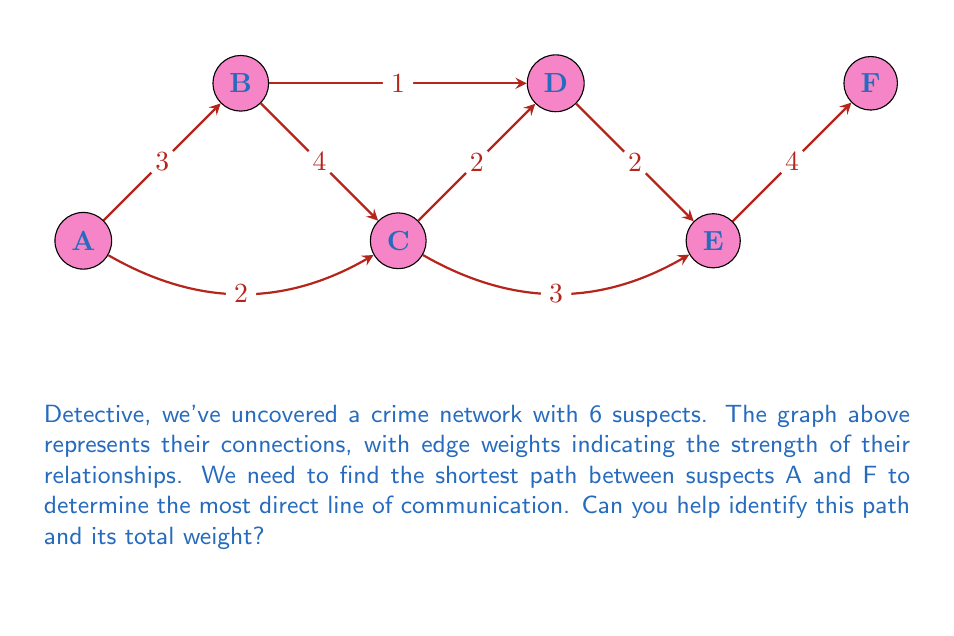Can you solve this math problem? To solve this problem, we'll use Dijkstra's algorithm to find the shortest path from A to F. Let's go through the steps:

1) Initialize:
   - Distance to A = 0
   - Distance to all other nodes = $\infty$
   - Set of unvisited nodes = {A, B, C, D, E, F}

2) Start from node A:
   - Update distances: B = 3, C = 2
   - Mark A as visited
   - Unvisited set = {B, C, D, E, F}

3) Choose the node with smallest distance (C):
   - Update distances: D = 2 + 2 = 4, E = 2 + 3 = 5
   - Mark C as visited
   - Unvisited set = {B, D, E, F}

4) Choose the node with smallest distance (B):
   - Update distance to D: min(4, 3 + 1) = 4 (no change)
   - Mark B as visited
   - Unvisited set = {D, E, F}

5) Choose the node with smallest distance (D):
   - Update distance to E: min(5, 4 + 2) = 5 (no change)
   - Mark D as visited
   - Unvisited set = {E, F}

6) Choose the node with smallest distance (E):
   - Update distance to F: 5 + 4 = 9
   - Mark E as visited
   - Unvisited set = {F}

7) Only F is left, so we're done.

The shortest path is A → C → D → E → F with a total weight of 9.
Answer: A → C → D → E → F, total weight 9 